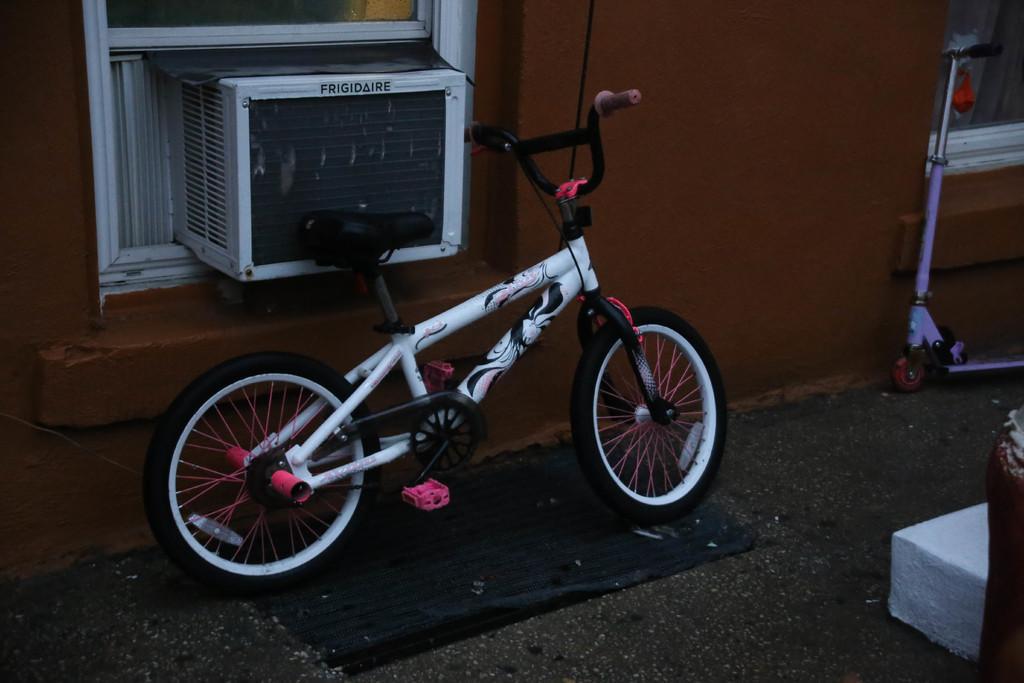In one or two sentences, can you explain what this image depicts? In the image there is a bicycle. Behind the bicycle there's a wall with glass window and inside the window there is an air conditioner. On the right corner of the image there is a wheel scooter cycle. In the bottom right corner of the image there is a white color thing. 